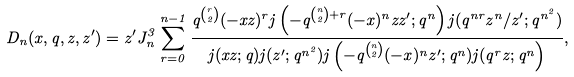<formula> <loc_0><loc_0><loc_500><loc_500>D _ { n } ( x , q , z , z ^ { \prime } ) = z ^ { \prime } J _ { n } ^ { 3 } \sum _ { r = 0 } ^ { n - 1 } \frac { q ^ { { \binom { r } { 2 } } } ( - x z ) ^ { r } j \left ( - q ^ { { \binom { n } { 2 } + r } } ( - x ) ^ { n } z z ^ { \prime } ; q ^ { n } \right ) j ( q ^ { n r } z ^ { n } / z ^ { \prime } ; q ^ { n ^ { 2 } } ) } { j ( x z ; q ) j ( z ^ { \prime } ; q ^ { n ^ { 2 } } ) j \left ( - q ^ { { \binom { n } { 2 } } } ( - x ) ^ { n } z ^ { \prime } ; q ^ { n } ) j ( q ^ { r } z ; q ^ { n } \right ) } ,</formula> 